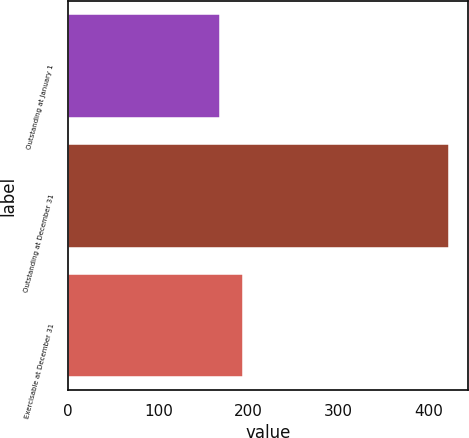Convert chart to OTSL. <chart><loc_0><loc_0><loc_500><loc_500><bar_chart><fcel>Outstanding at January 1<fcel>Outstanding at December 31<fcel>Exercisable at December 31<nl><fcel>169<fcel>423<fcel>194.4<nl></chart> 